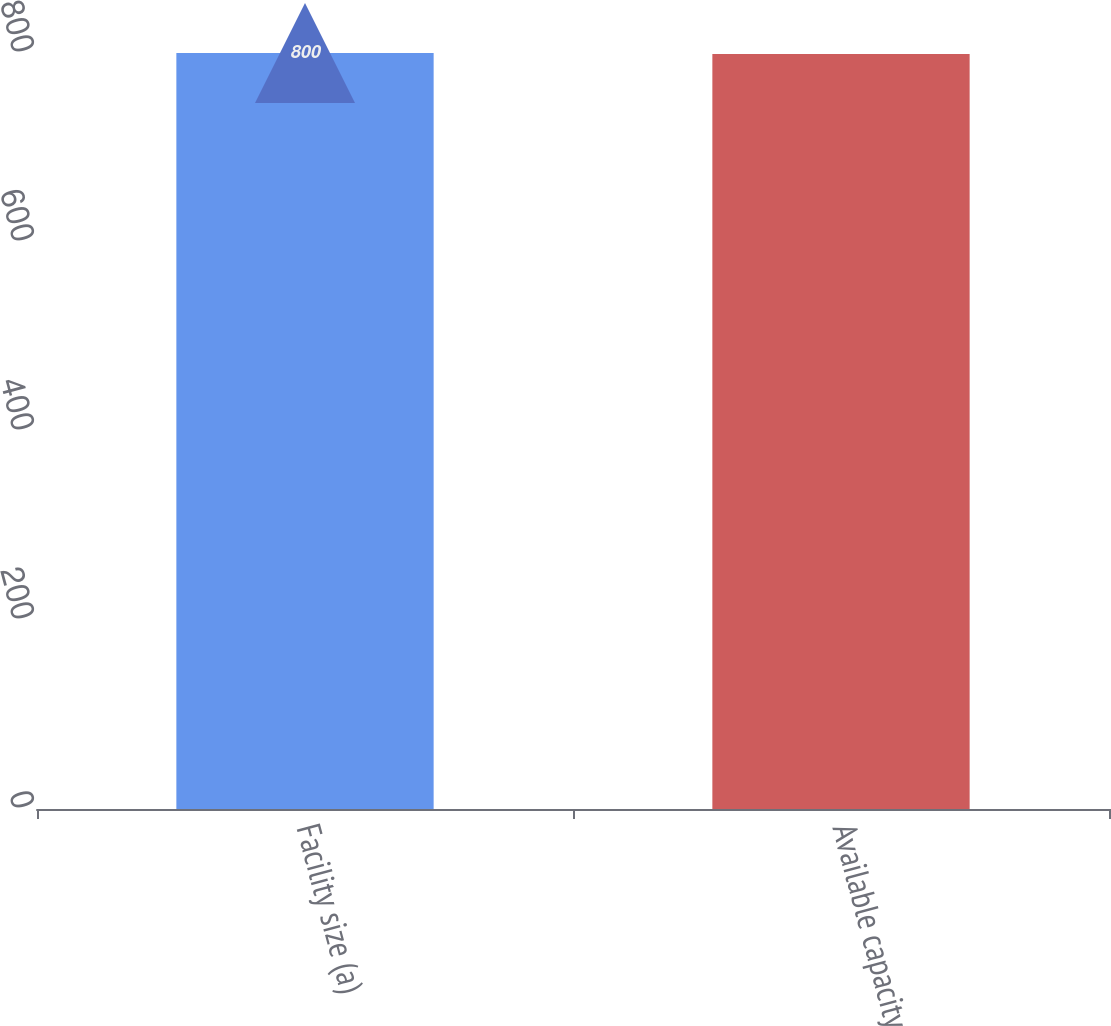Convert chart to OTSL. <chart><loc_0><loc_0><loc_500><loc_500><bar_chart><fcel>Facility size (a)<fcel>Available capacity<nl><fcel>800<fcel>799<nl></chart> 